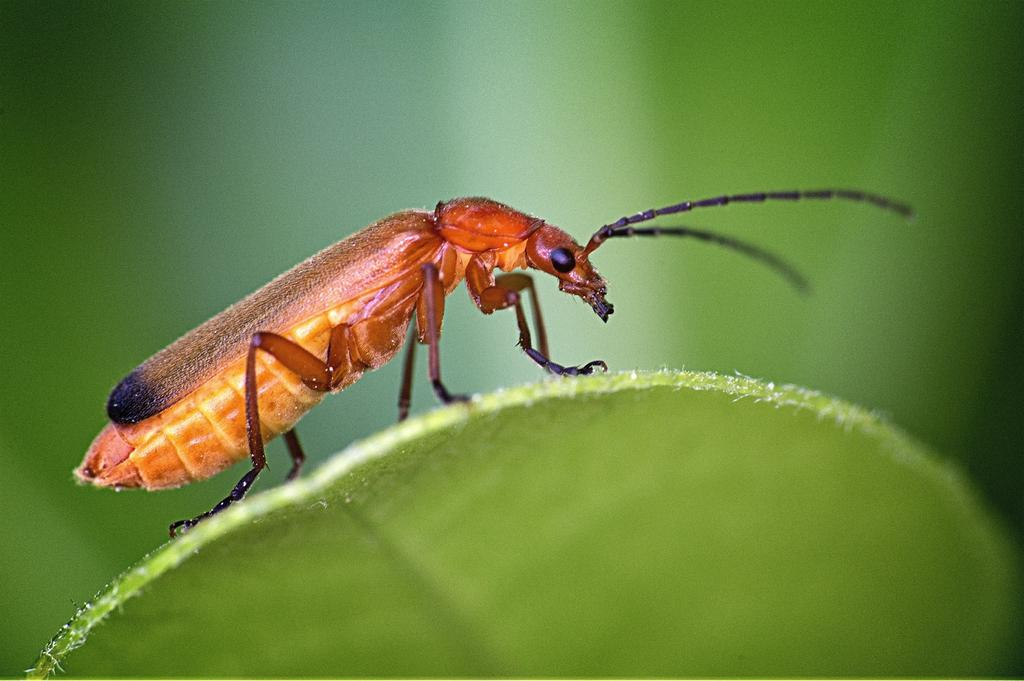What is present in the image? There is an insect in the image. Where is the insect located? The insect is on a leaf. What type of veil can be seen covering the corn in the image? There is no veil or corn present in the image; it only features an insect on a leaf. 